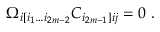Convert formula to latex. <formula><loc_0><loc_0><loc_500><loc_500>\Omega _ { i [ i _ { 1 } \dots i _ { 2 m - 2 } } C _ { i _ { 2 m - 1 } ] i j } = 0 \ .</formula> 